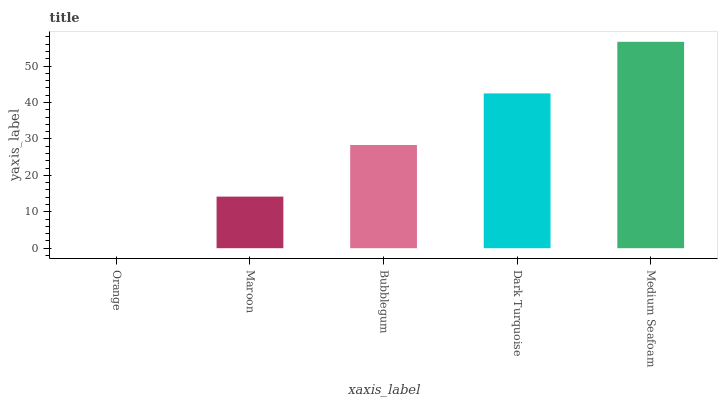Is Medium Seafoam the maximum?
Answer yes or no. Yes. Is Maroon the minimum?
Answer yes or no. No. Is Maroon the maximum?
Answer yes or no. No. Is Maroon greater than Orange?
Answer yes or no. Yes. Is Orange less than Maroon?
Answer yes or no. Yes. Is Orange greater than Maroon?
Answer yes or no. No. Is Maroon less than Orange?
Answer yes or no. No. Is Bubblegum the high median?
Answer yes or no. Yes. Is Bubblegum the low median?
Answer yes or no. Yes. Is Medium Seafoam the high median?
Answer yes or no. No. Is Medium Seafoam the low median?
Answer yes or no. No. 